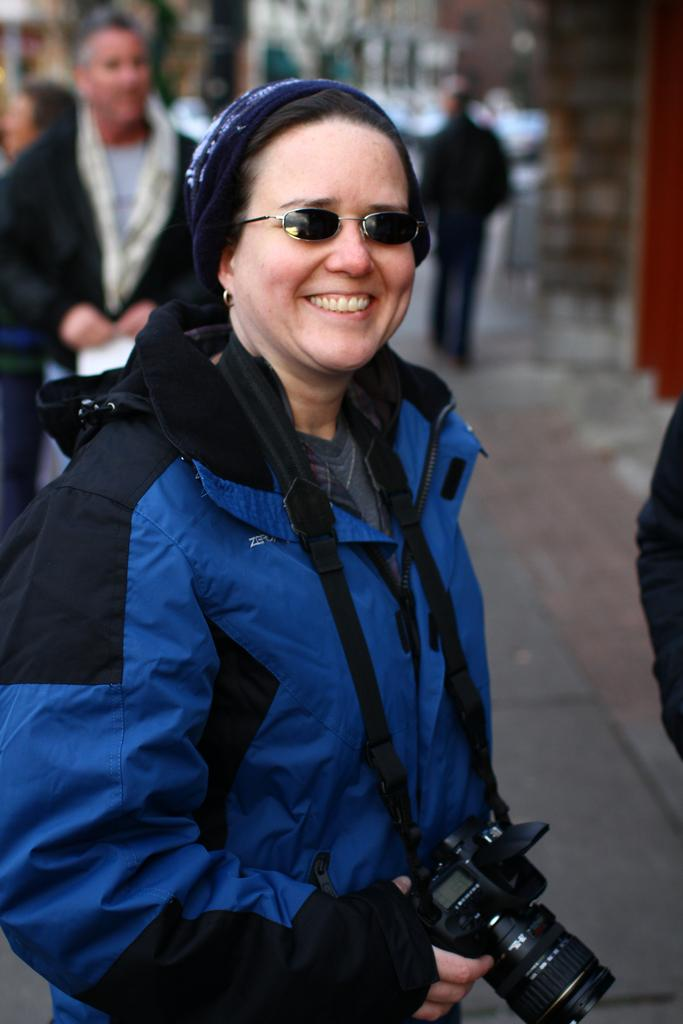Who is the main subject in the image? There is a woman in the image. What is the woman wearing on her upper body? The woman is wearing a blue jacket. What equipment is the woman carrying around her neck? The woman is wearing a camera around her neck. What protective gear is the woman wearing on her face? The woman is wearing goggles. What can be seen in the background of the image? There is a person walking in the background of the image, and the background includes a street. What type of apple is the woman holding in the image? There is no apple present in the image; the woman is wearing a camera around her neck. How does the wind affect the woman's goggles in the image? There is no mention of wind in the image, and the goggles are not affected by any wind. --- Facts: 1. There is a car in the image. 2. The car is red. 3. The car has four wheels. 4. The car has a license plate. 5. The car has a sunroof. Absurd Topics: bird, ocean, mountain Conversation: What is the main subject in the image? There is a car in the image. What color is the car? The car is red. How many wheels does the car have? The car has four wheels. What is attached to the car for identification purposes? The car has a license plate. What feature allows light and air into the car? The car has a sunroof. Reasoning: Let's think step by step in order to produce the conversation. We start by identifying the main subject in the image, which is the car. Then, we describe the color, number of wheels, and the presence of a license plate and sunroof. Each question is designed to elicit a specific detail about the image that is known from the provided facts. Absurd Question/Answer: Can you see any birds flying over the ocean near the mountain in the image? There are no birds, ocean, or mountains present in the image; it features a red car with four wheels, a license plate, and a sunroof. 